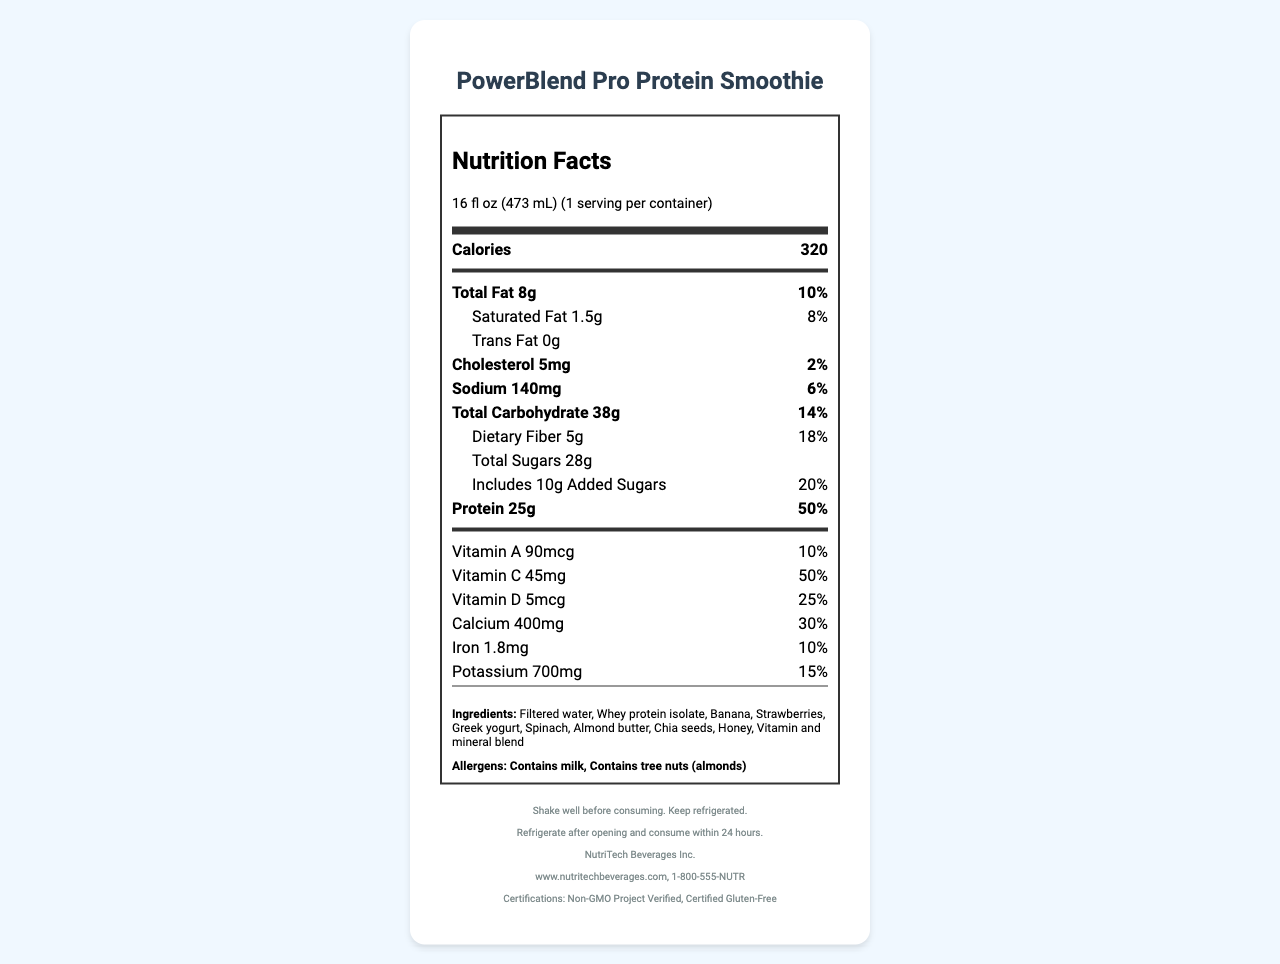when serving size is 16 fl oz? The document specifies that the serving size of "PowerBlend Pro Protein Smoothie" is 16 fl oz (473 mL), and there is 1 serving per container.
Answer: 1 serving How many calories are in one serving? According to the document, one serving of the smoothie contains 320 calories.
Answer: 320 What is the total fat content and its daily value percentage? The document indicates that the total fat content is 8g, which is 10% of the daily value.
Answer: 8g, 10% How much protein does the smoothie contain per serving? The document states that each serving contains 25 grams of protein.
Answer: 25g What are the main ingredients of the smoothie? The document lists these ingredients under the "Ingredients" section.
Answer: Filtered water, Whey protein isolate, Banana, Strawberries, Greek yogurt, Spinach, Almond butter, Chia seeds, Honey, Vitamin and mineral blend Which of the following vitamins is present in the highest daily value percentage? A. Vitamin A B. Vitamin C C. Vitamin D D. Vitamin B12 Vitamin B12 has the highest daily value percentage at 100%, followed by Vitamin C at 50%, Vitamin D at 25%, and Vitamin A at 10%.
Answer: D. Vitamin B12 What is the amount of sodium per serving? A. 140mg B. 160mg C. 180mg D. 200mg The nutritional information in the document indicates that the smoothie contains 140mg of sodium per serving.
Answer: A. 140mg Is this product certified gluten-free? The document notes that the smoothie is "Certified Gluten-Free."
Answer: Yes Summarize the nutritional content and features of "PowerBlend Pro Protein Smoothie." This summary provides an overview of the nutritional values, key ingredients, and certifications mentioned in the document.
Answer: The "PowerBlend Pro Protein Smoothie" is a protein-rich drink with 320 calories per serving, containing 25g of protein, 8g of total fat, 38g of total carbohydrates, and various vitamins and minerals. It is made from ingredients like whey protein isolate, bananas, strawberries, and spinach, and includes certifications such as Non-GMO and Gluten-Free. What is the barcode of the product? The document lists the barcode of the product as "123456789012."
Answer: 123456789012 What is the protein's daily value percentage? The protein content per serving contributes 50% toward the daily value, according to the document.
Answer: 50% Can you tell the sugar content from natural sources and added sugars separately? The document states that the total sugars amount to 28g, with 10g of these being added sugars.
Answer: Yes Is this smoothie suitable for someone with a tree nut allergy? The document clearly mentions that the product contains tree nuts (almonds), making it unsuitable for someone with a tree nut allergy.
Answer: No What is the source of additional nutritional supplements in the smoothie? The ingredients list indicates that a "Vitamin and mineral blend" is used to fortify the smoothie with additional nutrients.
Answer: Vitamin and mineral blend How long can the smoothie be stored after opening? The document advises that the product should be consumed within 24 hours after opening and kept refrigerated.
Answer: 24 hours Are the preparation instructions provided in the document sufficient for consumption? The preparation instructions provided are "Shake well before consuming. Keep refrigerated." These instructions are clear and sufficient for consumption.
Answer: Yes Does the document specify the RDA for all the vitamins listed? The document provides the daily value percentages (RDA) for several, but not all, vitamins; for instance, Vitamin E and Vitamin B12 are not given as percentages.
Answer: No What is the expiration date of the smoothie? The document does not provide any information regarding the expiration date of the product.
Answer: Cannot be determined Which company manufactures the smoothie? The document specifies that "NutriTech Beverages Inc." is the manufacturer of the product.
Answer: NutriTech Beverages Inc. 